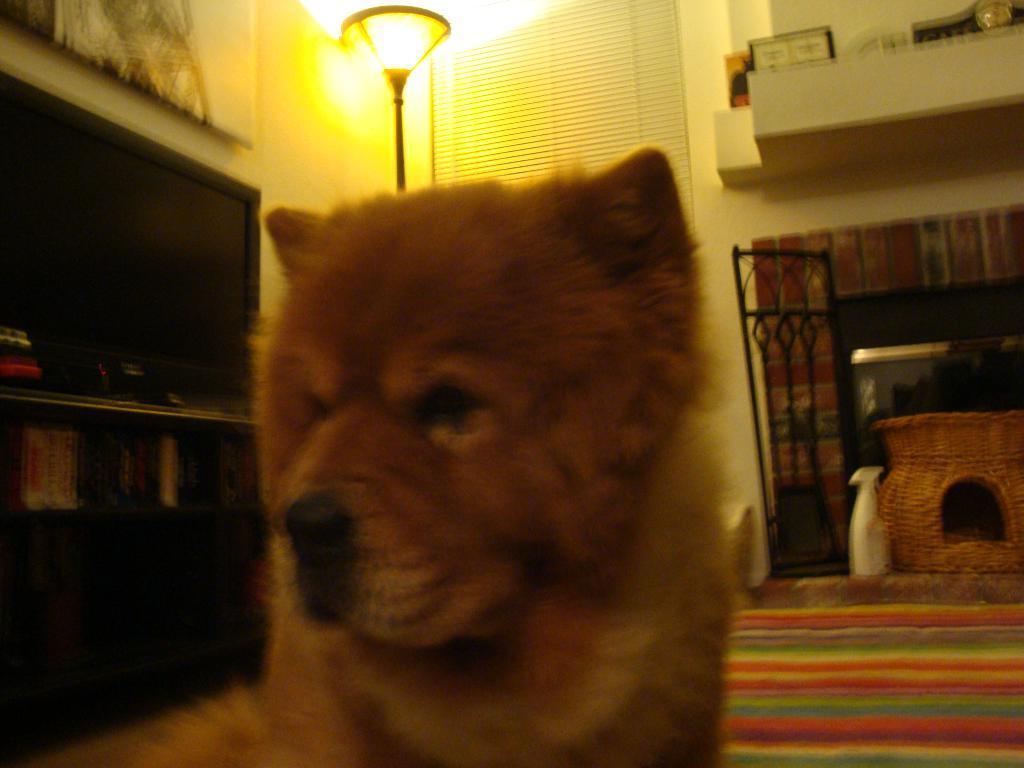Please provide a concise description of this image. In the image I can see a dog on the ground. In the background I can see lights, windows blind, shelf which has objects on it and some other on the floor. 